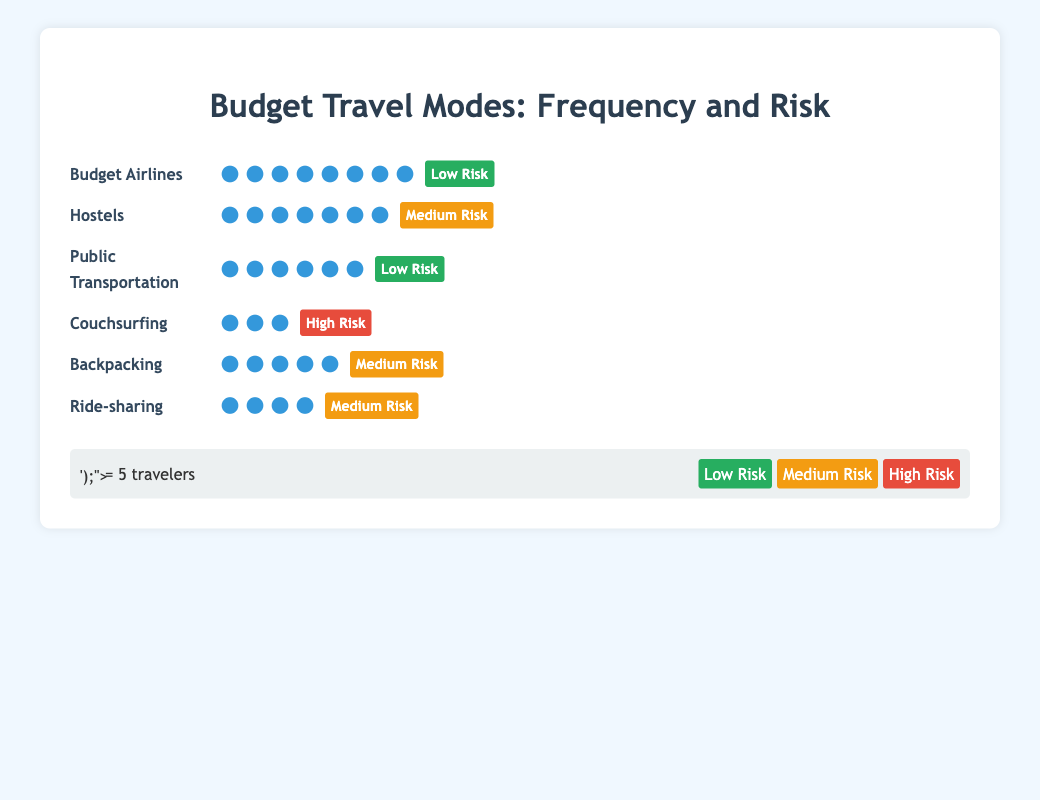What's the frequency of travelers using Budget Airlines? The figure shows `Budget Airlines` with 8 icons, with each icon representing 5 travelers. Multiplying 8 by 5 gives 40 travelers.
Answer: 40 Which travel mode has the highest risk? The figure uses color-coded backgrounds to indicate risk levels. `Couchsurfing` is marked with a red background for `High Risk`.
Answer: Couchsurfing Compare the frequency of travelers using Hostels and Public Transportation. Which one is more popular? The figure shows `Hostels` with 7 icons and `Public Transportation` with 6 icons. Since each icon represents 5 travelers, `Hostels` have a higher frequency (35 vs. 30 travelers).
Answer: Hostels What's the sum of the frequencies of travelers using Backpacking and Ride-sharing? `Backpacking` has 5 icons and `Ride-sharing` has 4 icons. Each icon stands for 5 travelers. Summing up: (5 * 5) + (4 * 5) = 25 + 20 = 45 travelers.
Answer: 45 Which travel modes are considered low risk? Low risk is shown with a green background. The figure shows `Budget Airlines` and `Public Transportation` marked as `Low Risk`.
Answer: Budget Airlines, Public Transportation What's the difference in frequency between the most and least popular travel modes? The most popular mode, `Budget Airlines` has 40 travelers. The least popular, `Couchsurfing`, has 15 travelers. The difference is 40 - 15 = 25 travelers.
Answer: 25 What's the total number of travel icons in the figure? Summing up all icons from all travel modes: 
8 (Budget Airlines) + 7 (Hostels) + 6 (Public Transportation) + 3 (Couchsurfing) + 5 (Backpacking) + 4 (Ride-sharing) = 33 icons.
Answer: 33 Which travel modes have the same risk level and what is that level? `Hostels`, `Backpacking`, and `Ride-sharing` all have an orange background indicating `Medium Risk`.
Answer: Hostels, Backpacking, Ride-sharing (Medium Risk) How many more travelers use Budget Airlines compared to Couchsurfing? Budget Airlines has 40 travelers, and Couchsurfing has 15 travelers. The difference is 40 - 15 = 25 travelers.
Answer: 25 